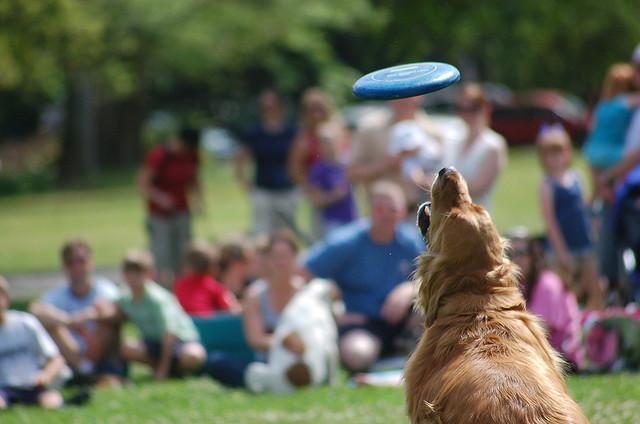How many dogs?
Give a very brief answer. 2. How many dogs can be seen?
Give a very brief answer. 2. How many people are there?
Give a very brief answer. 13. 